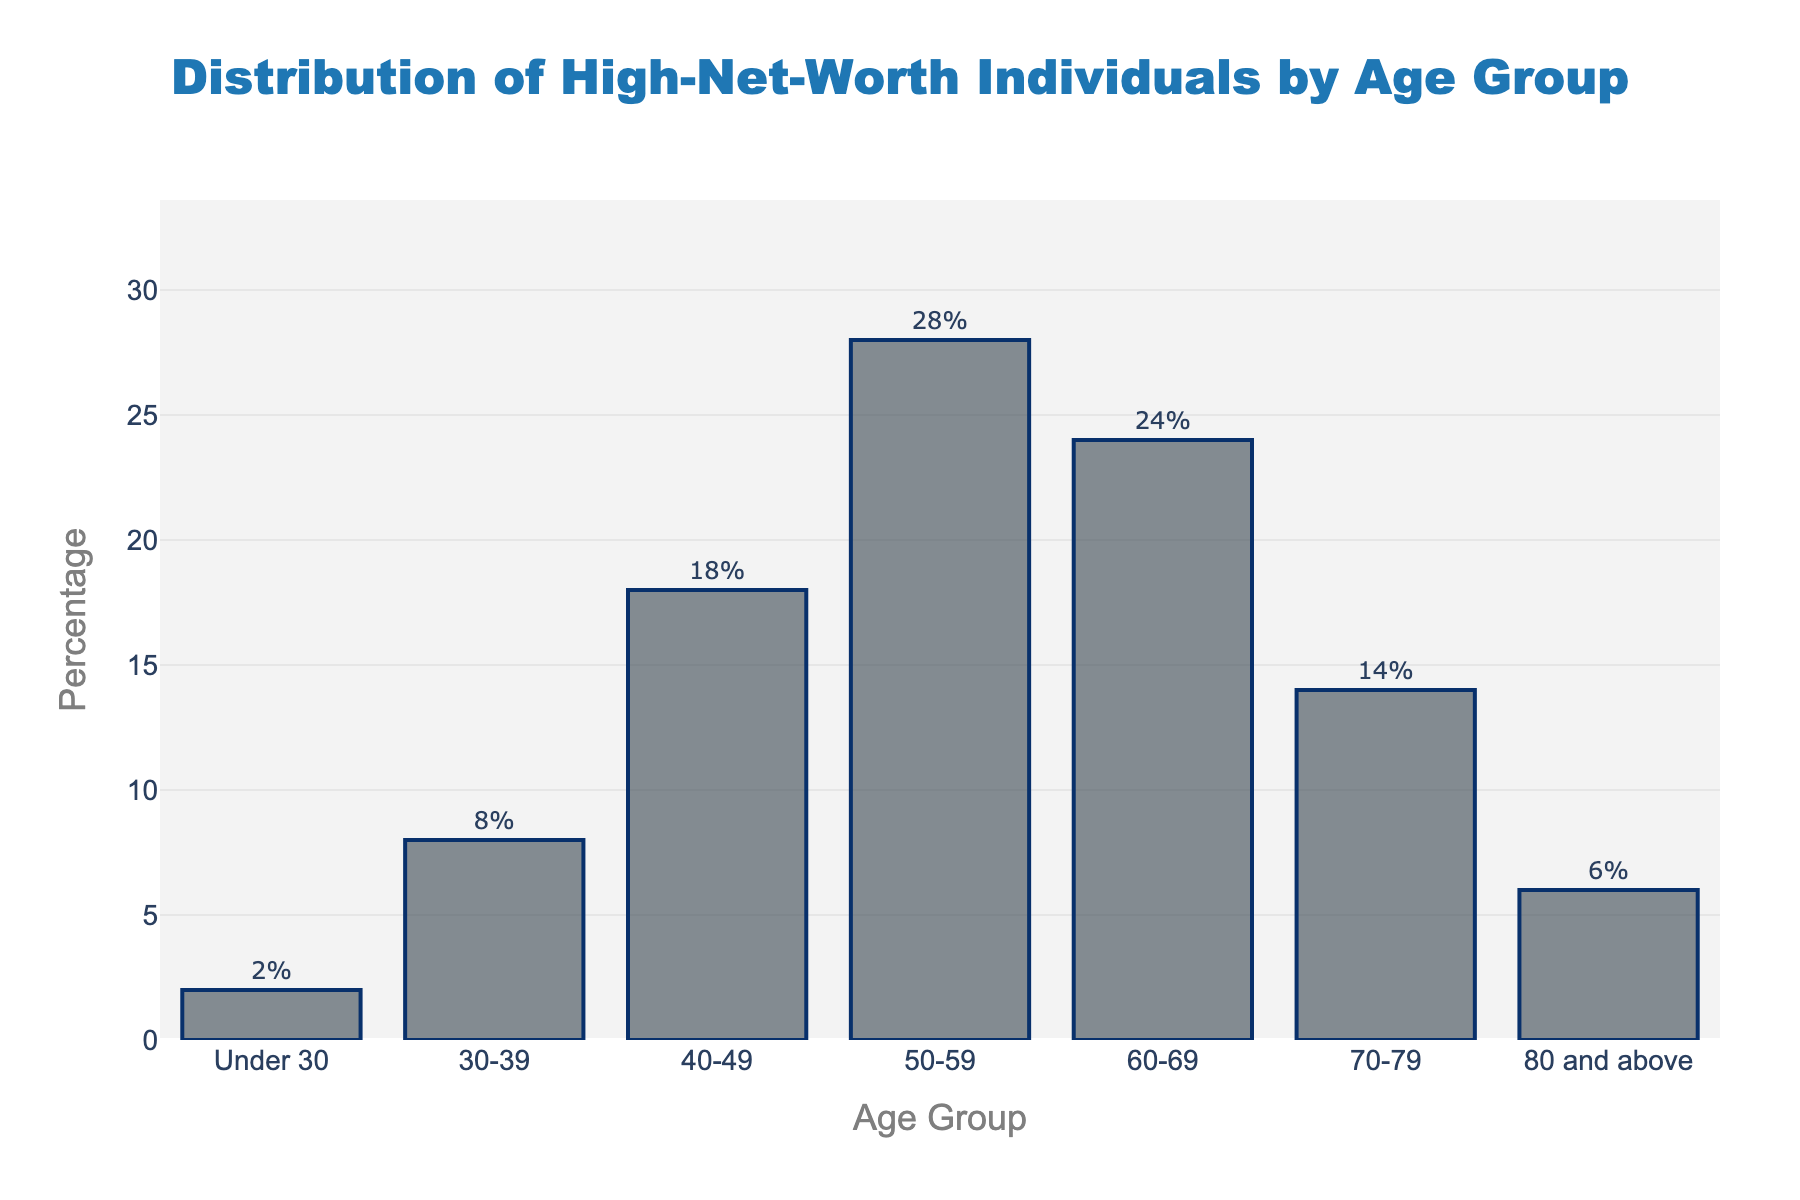What age group has the highest percentage of high-net-worth individuals? The bar corresponding to the 50-59 age group is the highest, indicating it has the highest percentage of high-net-worth individuals.
Answer: 50-59 What is the combined percentage of high-net-worth individuals in the age groups under 30 and 80 and above? The percentage for the under 30 age group is 2%, and for the 80 and above age group is 6%. Adding these together gives 2% + 6% = 8%.
Answer: 8% Which age group has less than a 10% share among high-net-worth individuals? Observing the heights of the bars, the 'Under 30' and '80 and above' age groups have percentages less than 10%. Specifically, their percentages are 2% and 6%, respectively.
Answer: Under 30 and 80 and above How much higher is the percentage of high-net-worth individuals in the 50-59 age group compared to the 40-49 age group? The percentage for the 50-59 age group is 28%, and for the 40-49 age group is 18%. The difference is 28% - 18% = 10%.
Answer: 10% Which age groups have a higher percentage of high-net-worth individuals than the 70-79 age group? The percentage for the 70-79 age group is 14%. Other age groups with higher percentages are 50-59 (28%), 60-69 (24%), and 40-49 (18%).
Answer: 50-59, 60-69, 40-49 What is the average percentage of high-net-worth individuals in the age groups from 40 to 59 (inclusive)? The percentages are 18% (40-49) and 28% (50-59). The average is (18% + 28%) / 2 = 23%.
Answer: 23% Which age group has the second highest percentage of high-net-worth individuals? The bar corresponding to the 60-69 age group is the second highest, indicating it has the second highest percentage of high-net-worth individuals.
Answer: 60-69 What is the total percentage of high-net-worth individuals aged 50 and above? Summing the percentages for the age groups 50-59 (28%), 60-69 (24%), 70-79 (14%), and 80 and above (6%) gives 28% + 24% + 14% + 6% = 72%.
Answer: 72% How does the percentage of high-net-worth individuals in the under 30 age group compare to the 70-79 age group? The percentage for the under 30 age group is 2%, whereas for the 70-79 age group it is 14%. The under 30 age group has a significantly lower percentage.
Answer: Lower Which visual characteristics can you identify in the bar representing the 50-59 age group? The bar is the tallest among all age groups, has a marker color with interleaved shades (darker borders), and the percentage value (28%) is displayed outside the bar.
Answer: Tall, shaded color, value displayed 